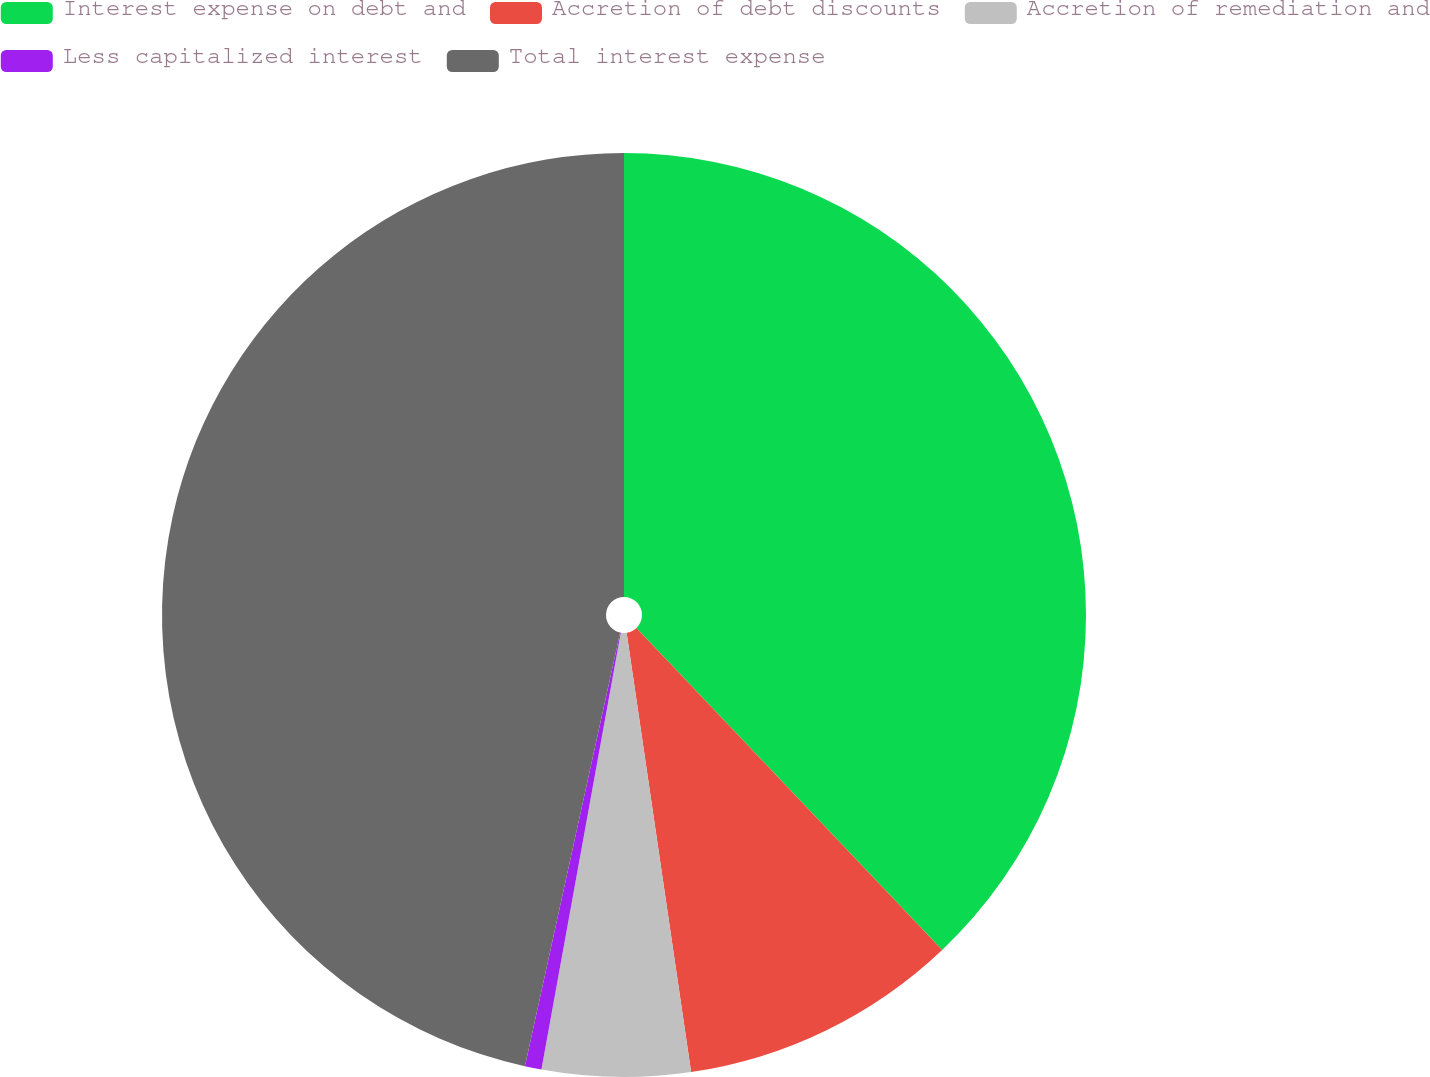<chart> <loc_0><loc_0><loc_500><loc_500><pie_chart><fcel>Interest expense on debt and<fcel>Accretion of debt discounts<fcel>Accretion of remediation and<fcel>Less capitalized interest<fcel>Total interest expense<nl><fcel>37.91%<fcel>9.77%<fcel>5.18%<fcel>0.58%<fcel>46.56%<nl></chart> 